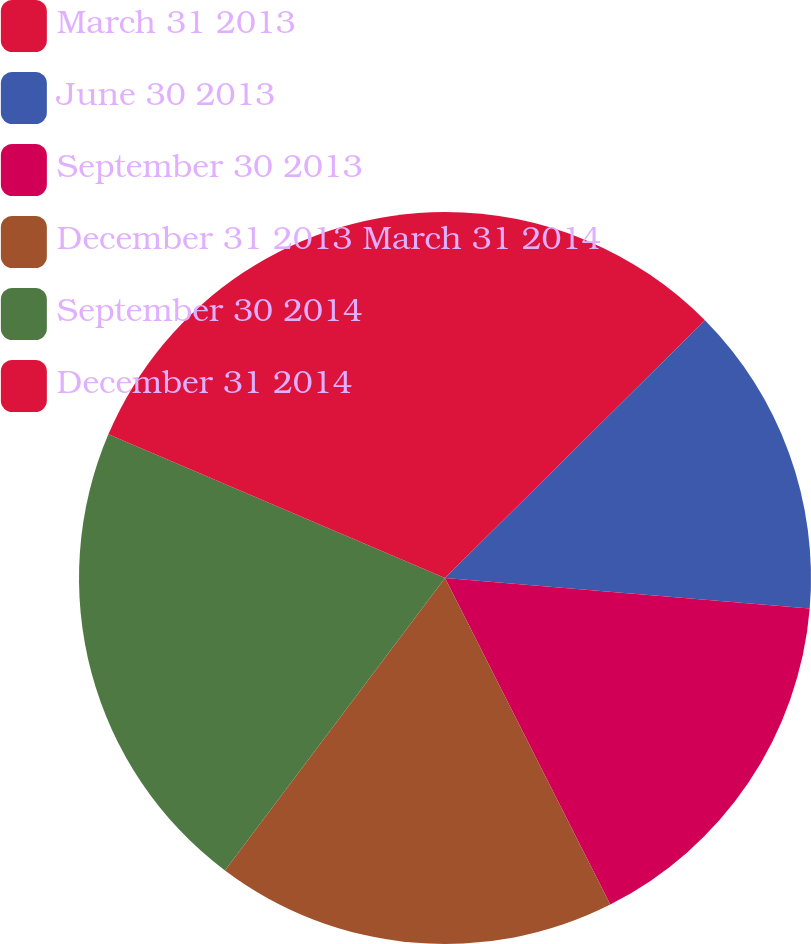Convert chart to OTSL. <chart><loc_0><loc_0><loc_500><loc_500><pie_chart><fcel>March 31 2013<fcel>June 30 2013<fcel>September 30 2013<fcel>December 31 2013 March 31 2014<fcel>September 30 2014<fcel>December 31 2014<nl><fcel>12.57%<fcel>13.76%<fcel>16.21%<fcel>17.72%<fcel>21.15%<fcel>18.58%<nl></chart> 